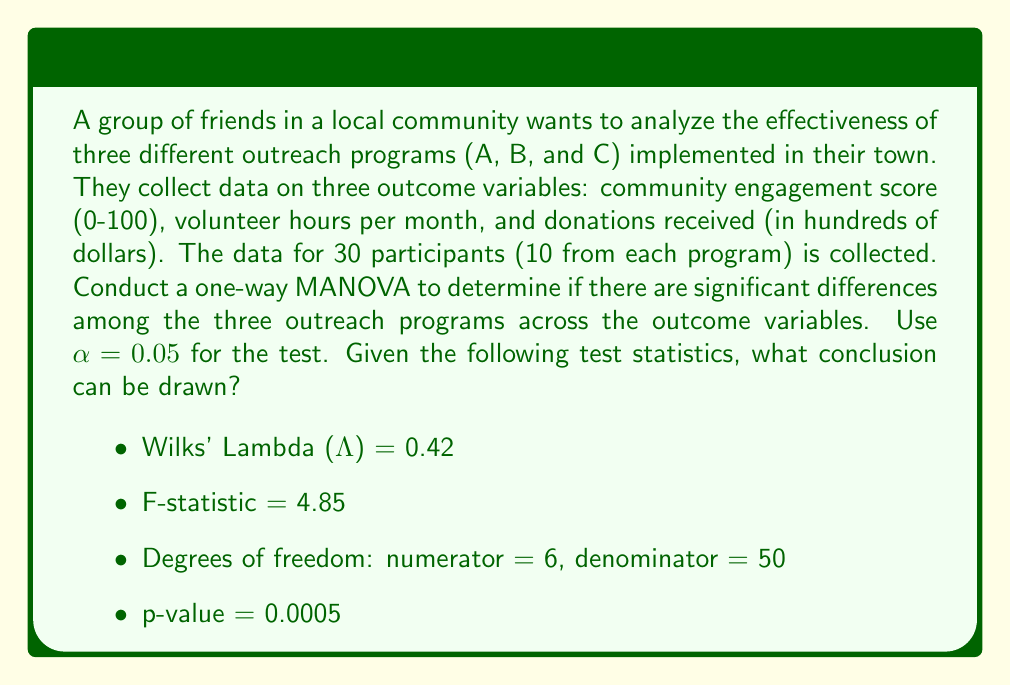Show me your answer to this math problem. To conduct a one-way MANOVA and interpret the results, we'll follow these steps:

1. State the hypotheses:
   $H_0$: There are no significant differences among the three outreach programs across the outcome variables.
   $H_a$: There are significant differences among the three outreach programs across the outcome variables.

2. Check the test statistic and p-value:
   - Wilks' Lambda (Λ) = 0.42
   - F-statistic = 4.85
   - Degrees of freedom: numerator = 6, denominator = 50
   - p-value = 0.0005

3. Compare the p-value to the significance level (α):
   p-value (0.0005) < α (0.05)

4. Interpret the results:
   Since the p-value (0.0005) is less than the significance level (0.05), we reject the null hypothesis.

5. Draw a conclusion:
   There is strong evidence to suggest that there are significant differences among the three outreach programs across the outcome variables (community engagement score, volunteer hours per month, and donations received).

Additional interpretation:
- Wilks' Lambda (Λ) ranges from 0 to 1, with values closer to 0 indicating stronger evidence against the null hypothesis. In this case, Λ = 0.42 suggests a moderate to strong effect.
- The F-statistic (4.85) with 6 and 50 degrees of freedom further supports the rejection of the null hypothesis, as it corresponds to the low p-value observed.

It's important to note that while the MANOVA tells us there are significant differences among the programs, it doesn't specify which programs differ or on which outcome variables. Follow-up analyses, such as univariate ANOVAs or discriminant function analysis, would be needed to determine the nature of these differences.
Answer: Reject the null hypothesis. There are significant differences among the three outreach programs across the outcome variables (p < 0.05). 